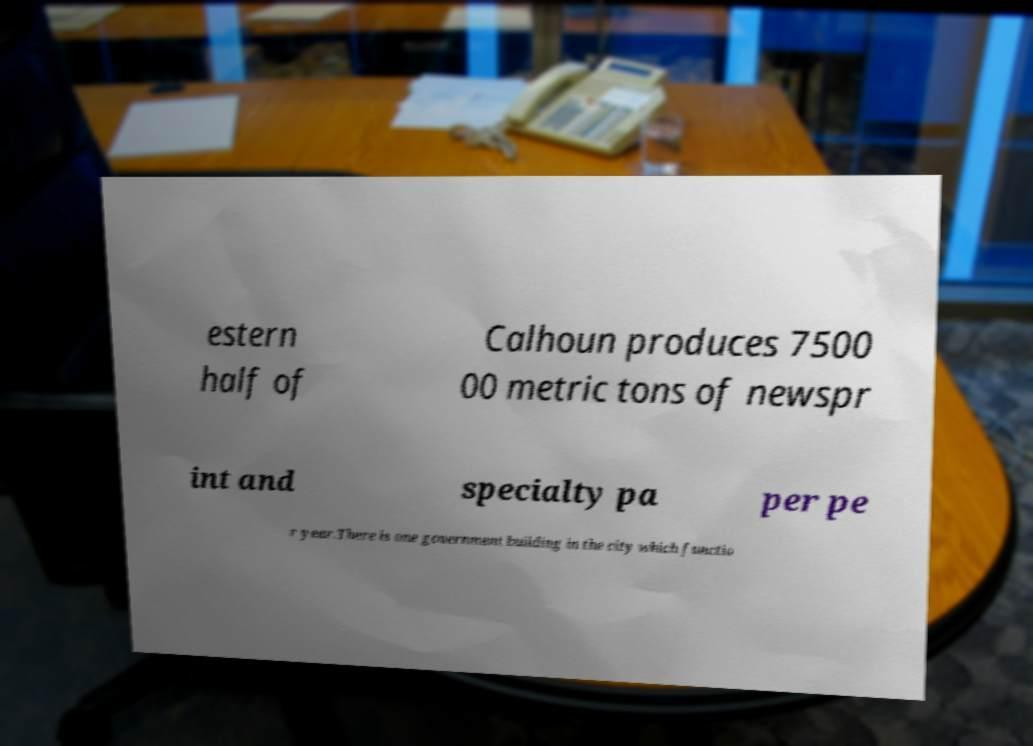Please identify and transcribe the text found in this image. estern half of Calhoun produces 7500 00 metric tons of newspr int and specialty pa per pe r year.There is one government building in the city which functio 